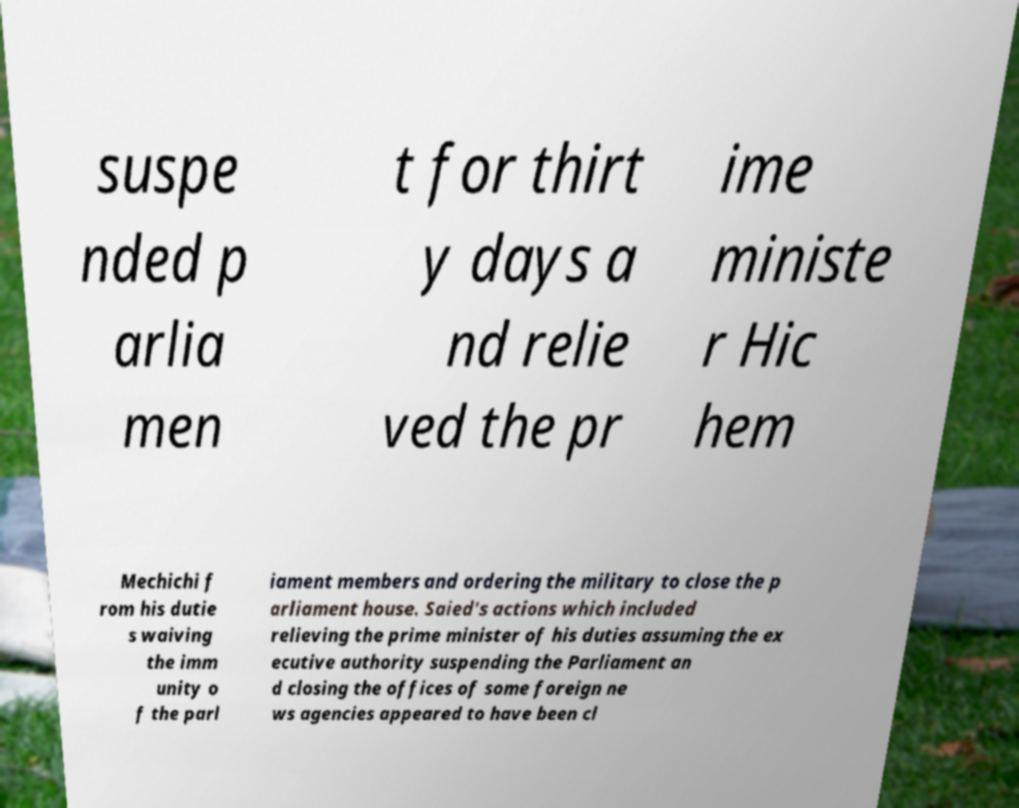There's text embedded in this image that I need extracted. Can you transcribe it verbatim? suspe nded p arlia men t for thirt y days a nd relie ved the pr ime ministe r Hic hem Mechichi f rom his dutie s waiving the imm unity o f the parl iament members and ordering the military to close the p arliament house. Saied's actions which included relieving the prime minister of his duties assuming the ex ecutive authority suspending the Parliament an d closing the offices of some foreign ne ws agencies appeared to have been cl 